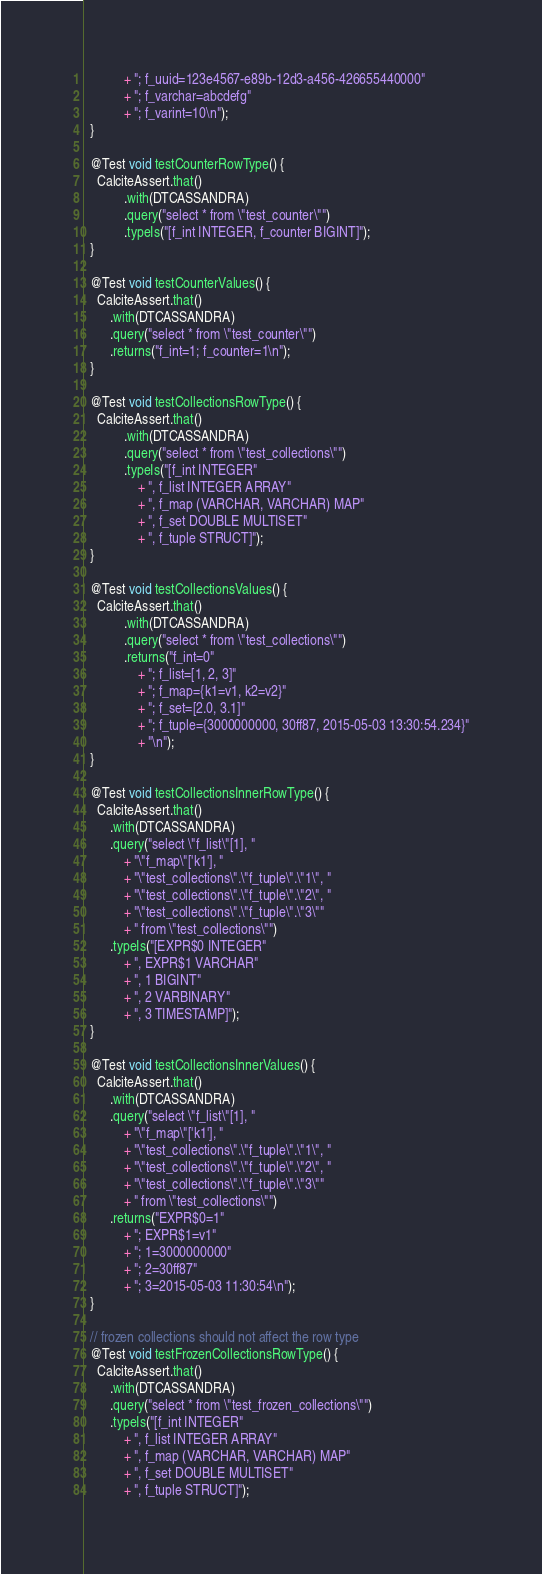<code> <loc_0><loc_0><loc_500><loc_500><_Java_>            + "; f_uuid=123e4567-e89b-12d3-a456-426655440000"
            + "; f_varchar=abcdefg"
            + "; f_varint=10\n");
  }

  @Test void testCounterRowType() {
    CalciteAssert.that()
            .with(DTCASSANDRA)
            .query("select * from \"test_counter\"")
            .typeIs("[f_int INTEGER, f_counter BIGINT]");
  }

  @Test void testCounterValues() {
    CalciteAssert.that()
        .with(DTCASSANDRA)
        .query("select * from \"test_counter\"")
        .returns("f_int=1; f_counter=1\n");
  }

  @Test void testCollectionsRowType() {
    CalciteAssert.that()
            .with(DTCASSANDRA)
            .query("select * from \"test_collections\"")
            .typeIs("[f_int INTEGER"
                + ", f_list INTEGER ARRAY"
                + ", f_map (VARCHAR, VARCHAR) MAP"
                + ", f_set DOUBLE MULTISET"
                + ", f_tuple STRUCT]");
  }

  @Test void testCollectionsValues() {
    CalciteAssert.that()
            .with(DTCASSANDRA)
            .query("select * from \"test_collections\"")
            .returns("f_int=0"
                + "; f_list=[1, 2, 3]"
                + "; f_map={k1=v1, k2=v2}"
                + "; f_set=[2.0, 3.1]"
                + "; f_tuple={3000000000, 30ff87, 2015-05-03 13:30:54.234}"
                + "\n");
  }

  @Test void testCollectionsInnerRowType() {
    CalciteAssert.that()
        .with(DTCASSANDRA)
        .query("select \"f_list\"[1], "
            + "\"f_map\"['k1'], "
            + "\"test_collections\".\"f_tuple\".\"1\", "
            + "\"test_collections\".\"f_tuple\".\"2\", "
            + "\"test_collections\".\"f_tuple\".\"3\""
            + " from \"test_collections\"")
        .typeIs("[EXPR$0 INTEGER"
            + ", EXPR$1 VARCHAR"
            + ", 1 BIGINT"
            + ", 2 VARBINARY"
            + ", 3 TIMESTAMP]");
  }

  @Test void testCollectionsInnerValues() {
    CalciteAssert.that()
        .with(DTCASSANDRA)
        .query("select \"f_list\"[1], "
            + "\"f_map\"['k1'], "
            + "\"test_collections\".\"f_tuple\".\"1\", "
            + "\"test_collections\".\"f_tuple\".\"2\", "
            + "\"test_collections\".\"f_tuple\".\"3\""
            + " from \"test_collections\"")
        .returns("EXPR$0=1"
            + "; EXPR$1=v1"
            + "; 1=3000000000"
            + "; 2=30ff87"
            + "; 3=2015-05-03 11:30:54\n");
  }

  // frozen collections should not affect the row type
  @Test void testFrozenCollectionsRowType() {
    CalciteAssert.that()
        .with(DTCASSANDRA)
        .query("select * from \"test_frozen_collections\"")
        .typeIs("[f_int INTEGER"
            + ", f_list INTEGER ARRAY"
            + ", f_map (VARCHAR, VARCHAR) MAP"
            + ", f_set DOUBLE MULTISET"
            + ", f_tuple STRUCT]");</code> 